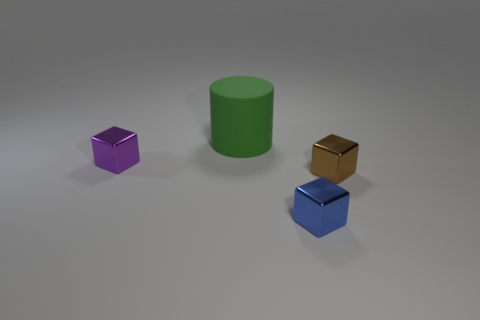Are there fewer small green cubes than objects?
Keep it short and to the point. Yes. Is the tiny cube that is in front of the small brown shiny cube made of the same material as the large green cylinder?
Keep it short and to the point. No. There is a thing behind the tiny purple shiny block; what material is it?
Make the answer very short. Rubber. There is a object that is to the right of the tiny metal cube that is in front of the brown metal block; what is its size?
Provide a short and direct response. Small. Are there any small purple things made of the same material as the green object?
Make the answer very short. No. There is a tiny object on the left side of the cube that is in front of the cube that is to the right of the small blue metal object; what shape is it?
Keep it short and to the point. Cube. Are there any other things that have the same size as the green object?
Give a very brief answer. No. There is a rubber thing; are there any small purple metal things on the left side of it?
Make the answer very short. Yes. What number of tiny brown things are the same shape as the tiny purple shiny thing?
Provide a short and direct response. 1. There is a thing that is behind the purple shiny cube that is to the left of the thing behind the small purple thing; what color is it?
Ensure brevity in your answer.  Green. 